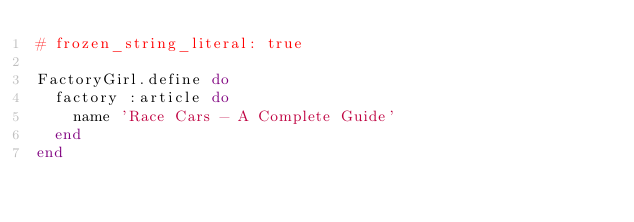<code> <loc_0><loc_0><loc_500><loc_500><_Ruby_># frozen_string_literal: true

FactoryGirl.define do
  factory :article do
    name 'Race Cars - A Complete Guide'
  end
end
</code> 